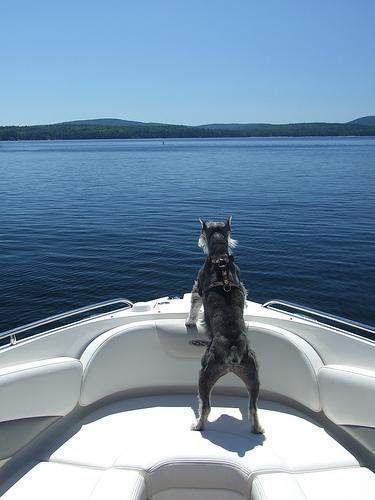How many animals are in the photo?
Give a very brief answer. 1. 